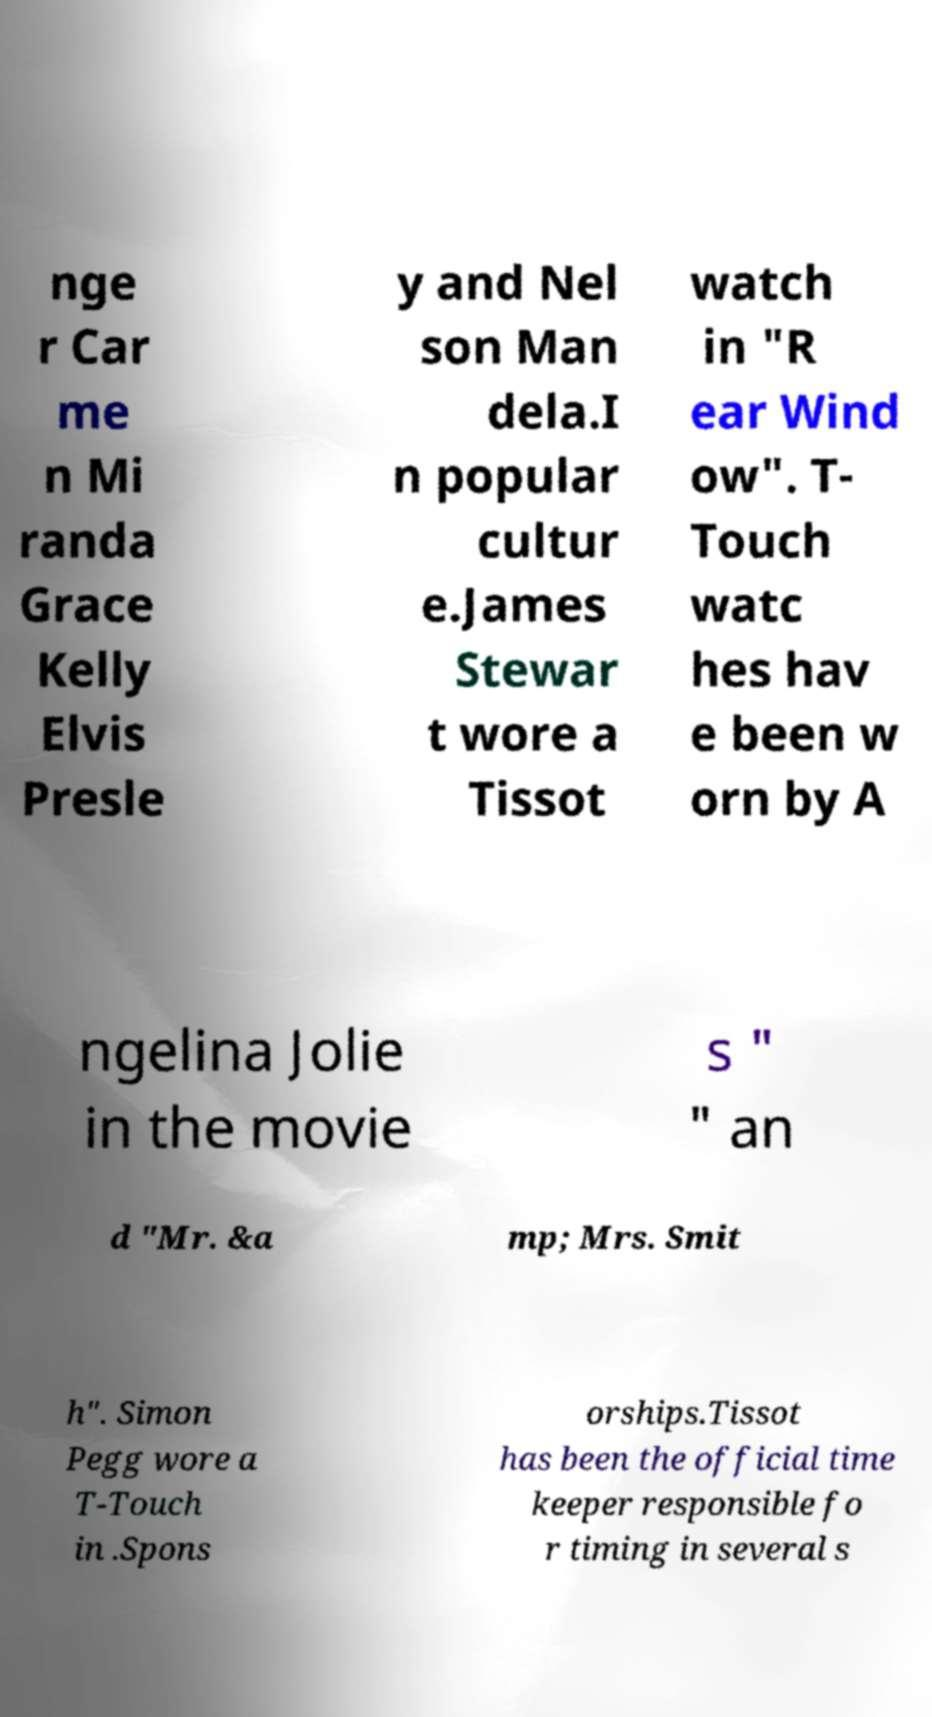Can you accurately transcribe the text from the provided image for me? nge r Car me n Mi randa Grace Kelly Elvis Presle y and Nel son Man dela.I n popular cultur e.James Stewar t wore a Tissot watch in "R ear Wind ow". T- Touch watc hes hav e been w orn by A ngelina Jolie in the movie s " " an d "Mr. &a mp; Mrs. Smit h". Simon Pegg wore a T-Touch in .Spons orships.Tissot has been the official time keeper responsible fo r timing in several s 